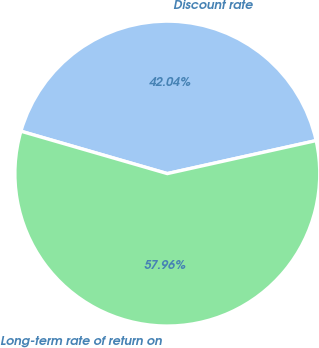<chart> <loc_0><loc_0><loc_500><loc_500><pie_chart><fcel>Discount rate<fcel>Long-term rate of return on<nl><fcel>42.04%<fcel>57.96%<nl></chart> 